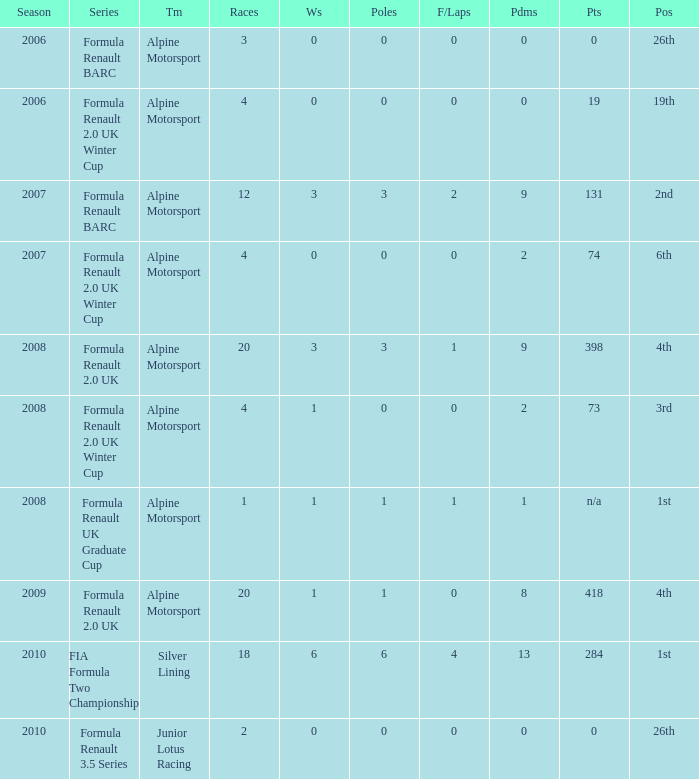How much were the f/laps if poles is higher than 1.0 during 2008? 1.0. 